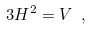<formula> <loc_0><loc_0><loc_500><loc_500>3 H ^ { 2 } = V \ ,</formula> 